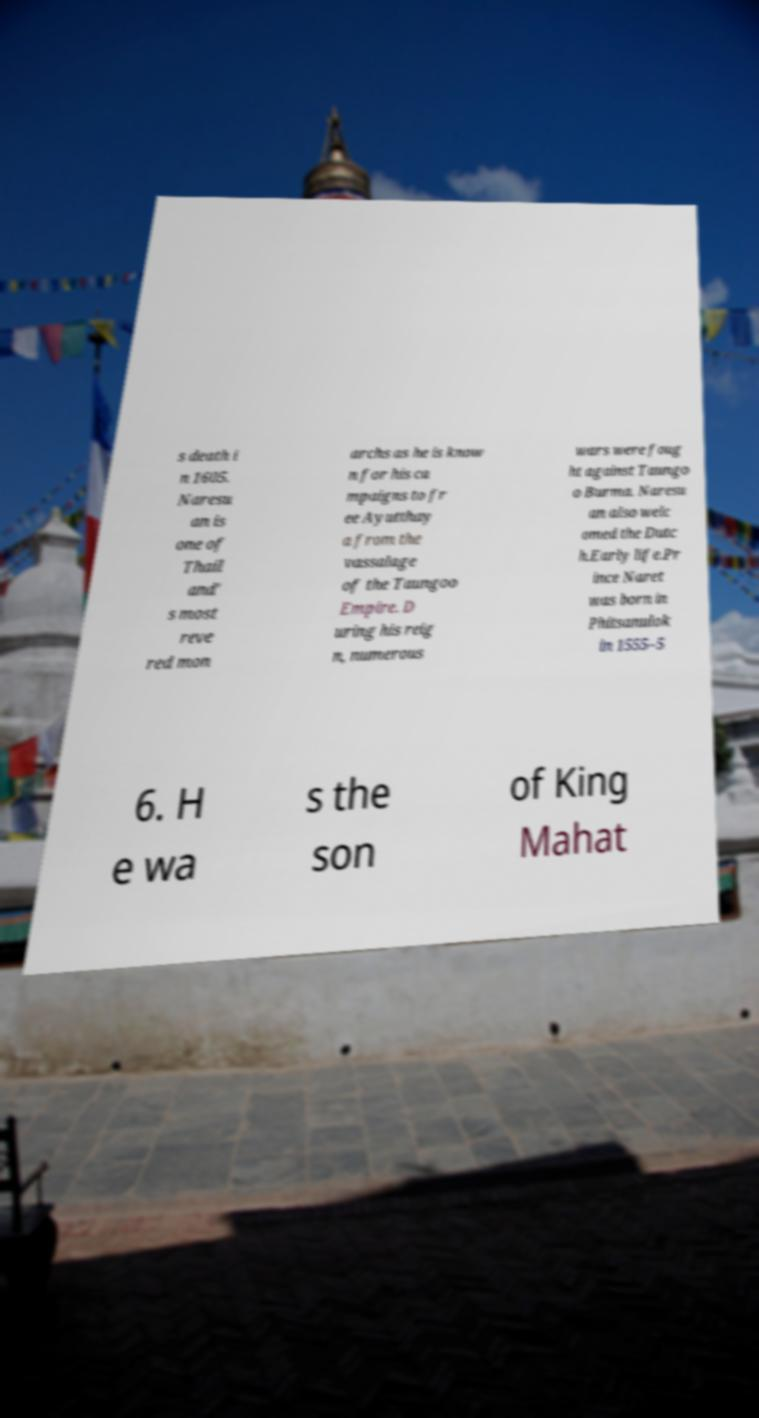There's text embedded in this image that I need extracted. Can you transcribe it verbatim? s death i n 1605. Naresu an is one of Thail and' s most reve red mon archs as he is know n for his ca mpaigns to fr ee Ayutthay a from the vassalage of the Taungoo Empire. D uring his reig n, numerous wars were foug ht against Taungo o Burma. Naresu an also welc omed the Dutc h.Early life.Pr ince Naret was born in Phitsanulok in 1555–5 6. H e wa s the son of King Mahat 